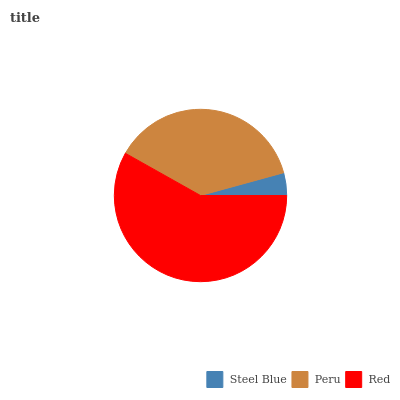Is Steel Blue the minimum?
Answer yes or no. Yes. Is Red the maximum?
Answer yes or no. Yes. Is Peru the minimum?
Answer yes or no. No. Is Peru the maximum?
Answer yes or no. No. Is Peru greater than Steel Blue?
Answer yes or no. Yes. Is Steel Blue less than Peru?
Answer yes or no. Yes. Is Steel Blue greater than Peru?
Answer yes or no. No. Is Peru less than Steel Blue?
Answer yes or no. No. Is Peru the high median?
Answer yes or no. Yes. Is Peru the low median?
Answer yes or no. Yes. Is Steel Blue the high median?
Answer yes or no. No. Is Steel Blue the low median?
Answer yes or no. No. 